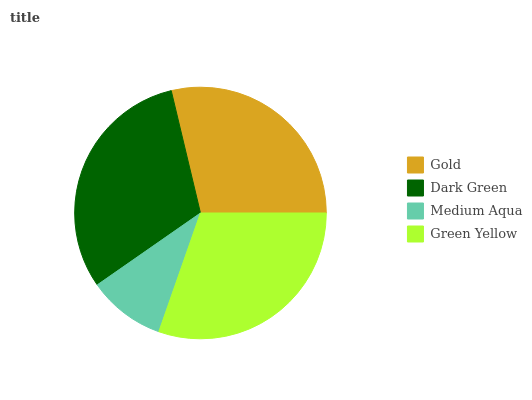Is Medium Aqua the minimum?
Answer yes or no. Yes. Is Dark Green the maximum?
Answer yes or no. Yes. Is Dark Green the minimum?
Answer yes or no. No. Is Medium Aqua the maximum?
Answer yes or no. No. Is Dark Green greater than Medium Aqua?
Answer yes or no. Yes. Is Medium Aqua less than Dark Green?
Answer yes or no. Yes. Is Medium Aqua greater than Dark Green?
Answer yes or no. No. Is Dark Green less than Medium Aqua?
Answer yes or no. No. Is Green Yellow the high median?
Answer yes or no. Yes. Is Gold the low median?
Answer yes or no. Yes. Is Gold the high median?
Answer yes or no. No. Is Dark Green the low median?
Answer yes or no. No. 